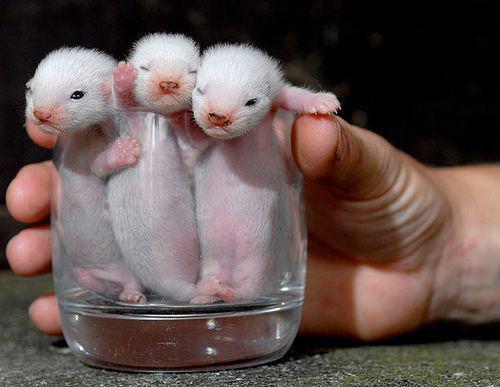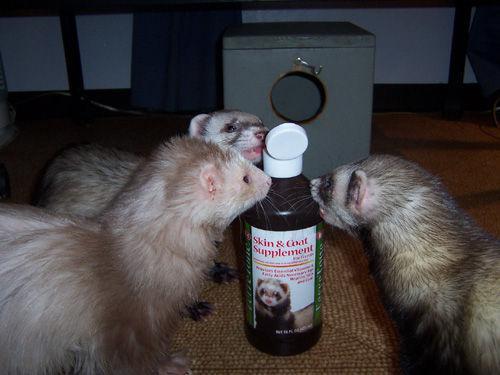The first image is the image on the left, the second image is the image on the right. Given the left and right images, does the statement "The right image contains exactly one ferret." hold true? Answer yes or no. No. The first image is the image on the left, the second image is the image on the right. Assess this claim about the two images: "Some ferrets are in a container.". Correct or not? Answer yes or no. Yes. 